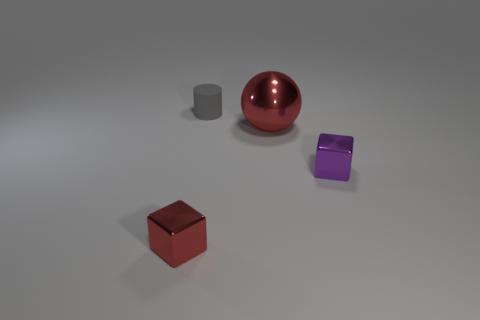Are there fewer blocks on the left side of the small purple thing than small brown cubes?
Your response must be concise. No. Are there any small metallic cylinders?
Ensure brevity in your answer.  No. There is another metallic object that is the same shape as the purple object; what color is it?
Give a very brief answer. Red. Do the shiny thing on the left side of the large metallic ball and the cylinder have the same color?
Keep it short and to the point. No. Do the metallic sphere and the red block have the same size?
Your answer should be very brief. No. There is a big object that is made of the same material as the tiny red cube; what is its shape?
Provide a short and direct response. Sphere. How many other objects are there of the same shape as the big metal object?
Your answer should be compact. 0. What is the shape of the metallic object behind the tiny cube on the right side of the small object left of the gray rubber object?
Your answer should be very brief. Sphere. What number of cylinders are small gray objects or small brown things?
Keep it short and to the point. 1. Are there any tiny purple shiny cubes that are behind the tiny metal block that is to the left of the purple block?
Your response must be concise. Yes. 